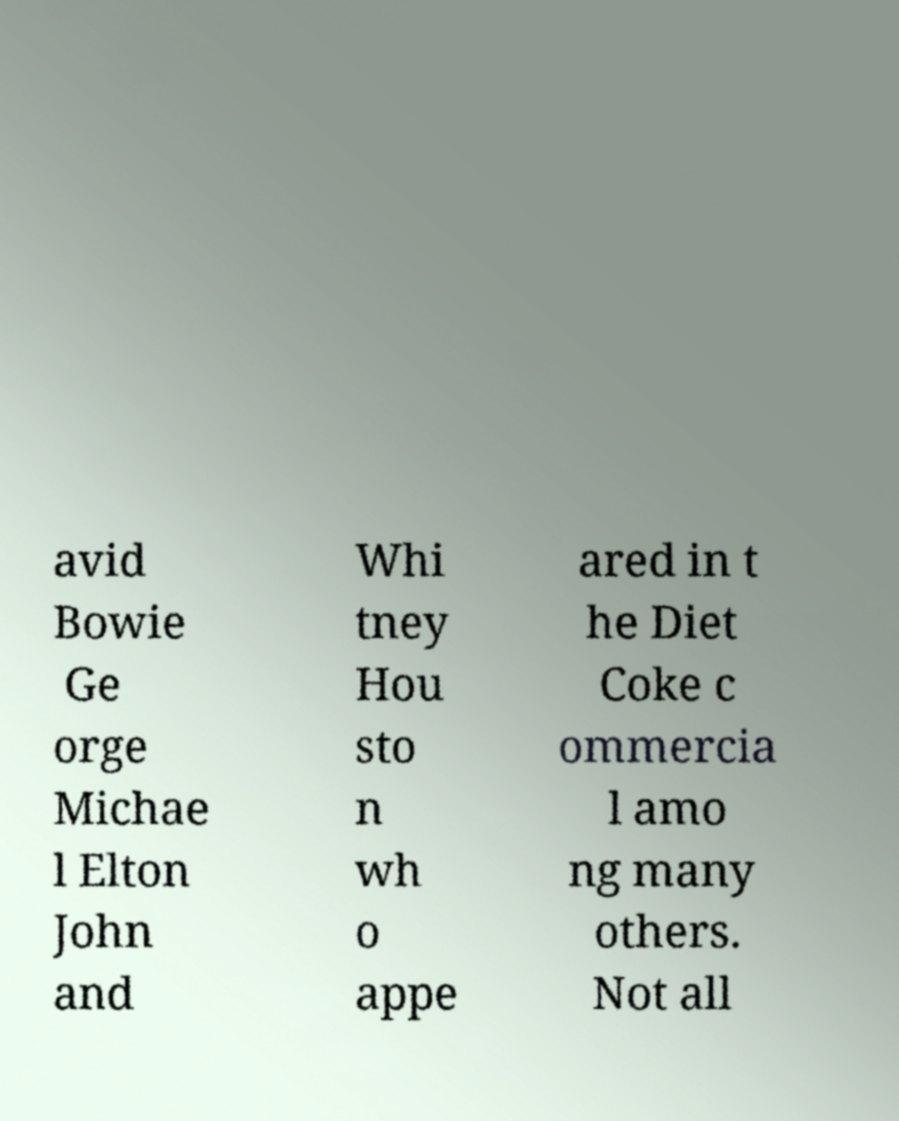Could you extract and type out the text from this image? avid Bowie Ge orge Michae l Elton John and Whi tney Hou sto n wh o appe ared in t he Diet Coke c ommercia l amo ng many others. Not all 